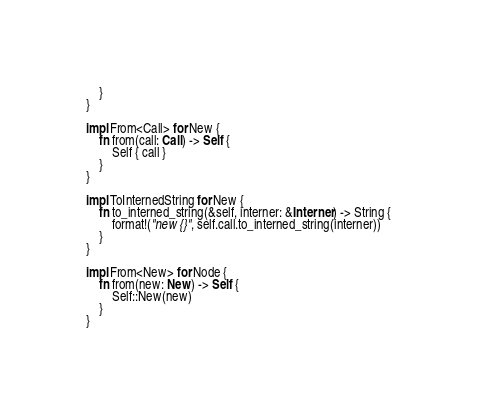<code> <loc_0><loc_0><loc_500><loc_500><_Rust_>    }
}

impl From<Call> for New {
    fn from(call: Call) -> Self {
        Self { call }
    }
}

impl ToInternedString for New {
    fn to_interned_string(&self, interner: &Interner) -> String {
        format!("new {}", self.call.to_interned_string(interner))
    }
}

impl From<New> for Node {
    fn from(new: New) -> Self {
        Self::New(new)
    }
}
</code> 